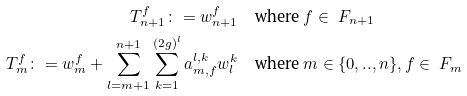Convert formula to latex. <formula><loc_0><loc_0><loc_500><loc_500>T ^ { f } _ { n + 1 } \colon = w ^ { f } _ { n + 1 } & \quad \text {where } f \in \ F _ { n + 1 } \\ T ^ { f } _ { m } \colon = w ^ { f } _ { m } + \sum _ { l = m + 1 } ^ { n + 1 } \sum _ { k = 1 } ^ { ( 2 g ) ^ { l } } a _ { m , f } ^ { l , k } w ^ { k } _ { l } & \quad \text {where } m \in \{ 0 , . . , n \} , f \in \ F _ { m }</formula> 